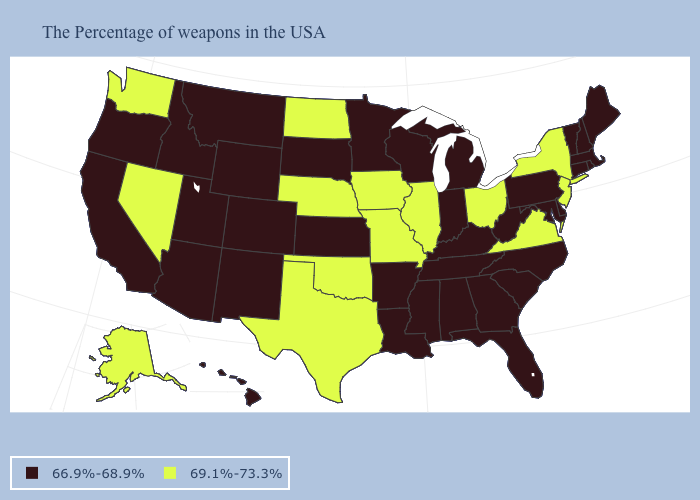Does South Carolina have the same value as North Dakota?
Answer briefly. No. Among the states that border Montana , which have the lowest value?
Write a very short answer. South Dakota, Wyoming, Idaho. Name the states that have a value in the range 69.1%-73.3%?
Be succinct. New York, New Jersey, Virginia, Ohio, Illinois, Missouri, Iowa, Nebraska, Oklahoma, Texas, North Dakota, Nevada, Washington, Alaska. Which states hav the highest value in the West?
Concise answer only. Nevada, Washington, Alaska. Name the states that have a value in the range 69.1%-73.3%?
Be succinct. New York, New Jersey, Virginia, Ohio, Illinois, Missouri, Iowa, Nebraska, Oklahoma, Texas, North Dakota, Nevada, Washington, Alaska. Does Washington have the lowest value in the USA?
Give a very brief answer. No. How many symbols are there in the legend?
Give a very brief answer. 2. Which states have the lowest value in the South?
Short answer required. Delaware, Maryland, North Carolina, South Carolina, West Virginia, Florida, Georgia, Kentucky, Alabama, Tennessee, Mississippi, Louisiana, Arkansas. Does New Jersey have the highest value in the Northeast?
Concise answer only. Yes. Does the map have missing data?
Give a very brief answer. No. What is the value of Tennessee?
Concise answer only. 66.9%-68.9%. Does North Dakota have the highest value in the USA?
Be succinct. Yes. Name the states that have a value in the range 69.1%-73.3%?
Short answer required. New York, New Jersey, Virginia, Ohio, Illinois, Missouri, Iowa, Nebraska, Oklahoma, Texas, North Dakota, Nevada, Washington, Alaska. What is the lowest value in states that border New Mexico?
Concise answer only. 66.9%-68.9%. 